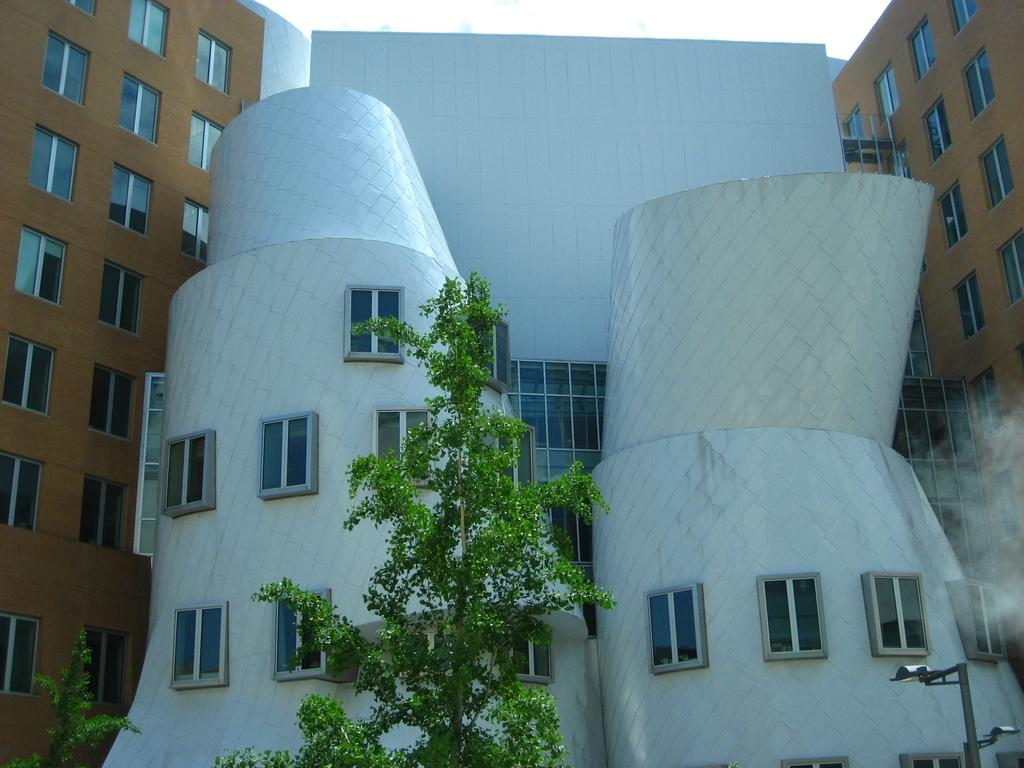What type of structures are visible in the image? There are buildings in the image. What type of vegetation is present at the bottom of the image? There are trees at the bottom of the image. What object can be seen standing upright in the image? There is a pole in the image. How many sisters are depicted in the image? There are no sisters present in the image. What type of prison can be seen in the image? There is no prison present in the image. 